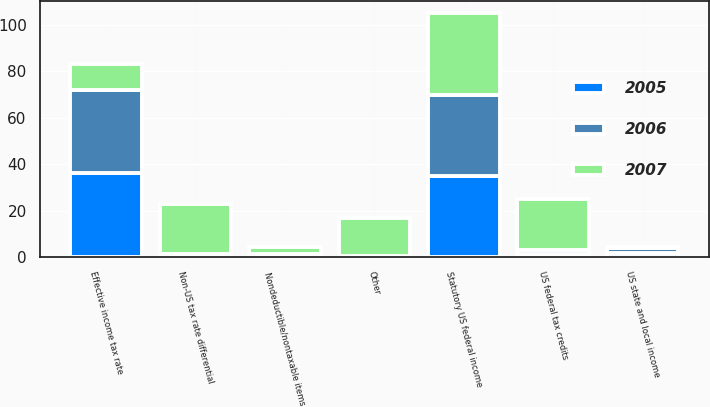<chart> <loc_0><loc_0><loc_500><loc_500><stacked_bar_chart><ecel><fcel>Statutory US federal income<fcel>US state and local income<fcel>Non-US tax rate differential<fcel>Nondeductible/nontaxable items<fcel>US federal tax credits<fcel>Other<fcel>Effective income tax rate<nl><fcel>2007<fcel>35<fcel>0.5<fcel>21.6<fcel>3.1<fcel>22<fcel>16.5<fcel>11.5<nl><fcel>2006<fcel>35<fcel>2.2<fcel>1.2<fcel>1.4<fcel>2<fcel>0.1<fcel>35.5<nl><fcel>2005<fcel>35<fcel>2<fcel>0.2<fcel>0.1<fcel>1.3<fcel>0.5<fcel>36.3<nl></chart> 